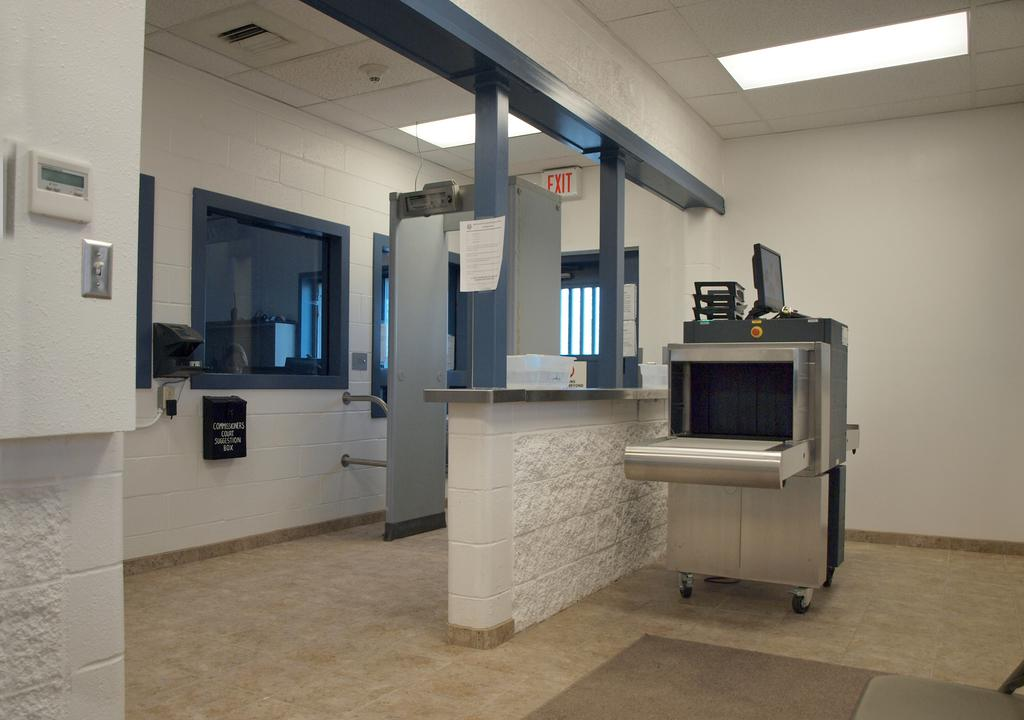What type of objects can be seen in the image? There are electronic gadgets in the image. Can you describe any architectural features in the image? There is a window in the image. Where is the nest of the frogs in the image? There is no nest or frogs present in the image. Can you tell me how many chess pieces are on the table in the image? There is no table or chess pieces visible in the image. 